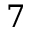<formula> <loc_0><loc_0><loc_500><loc_500>7</formula> 